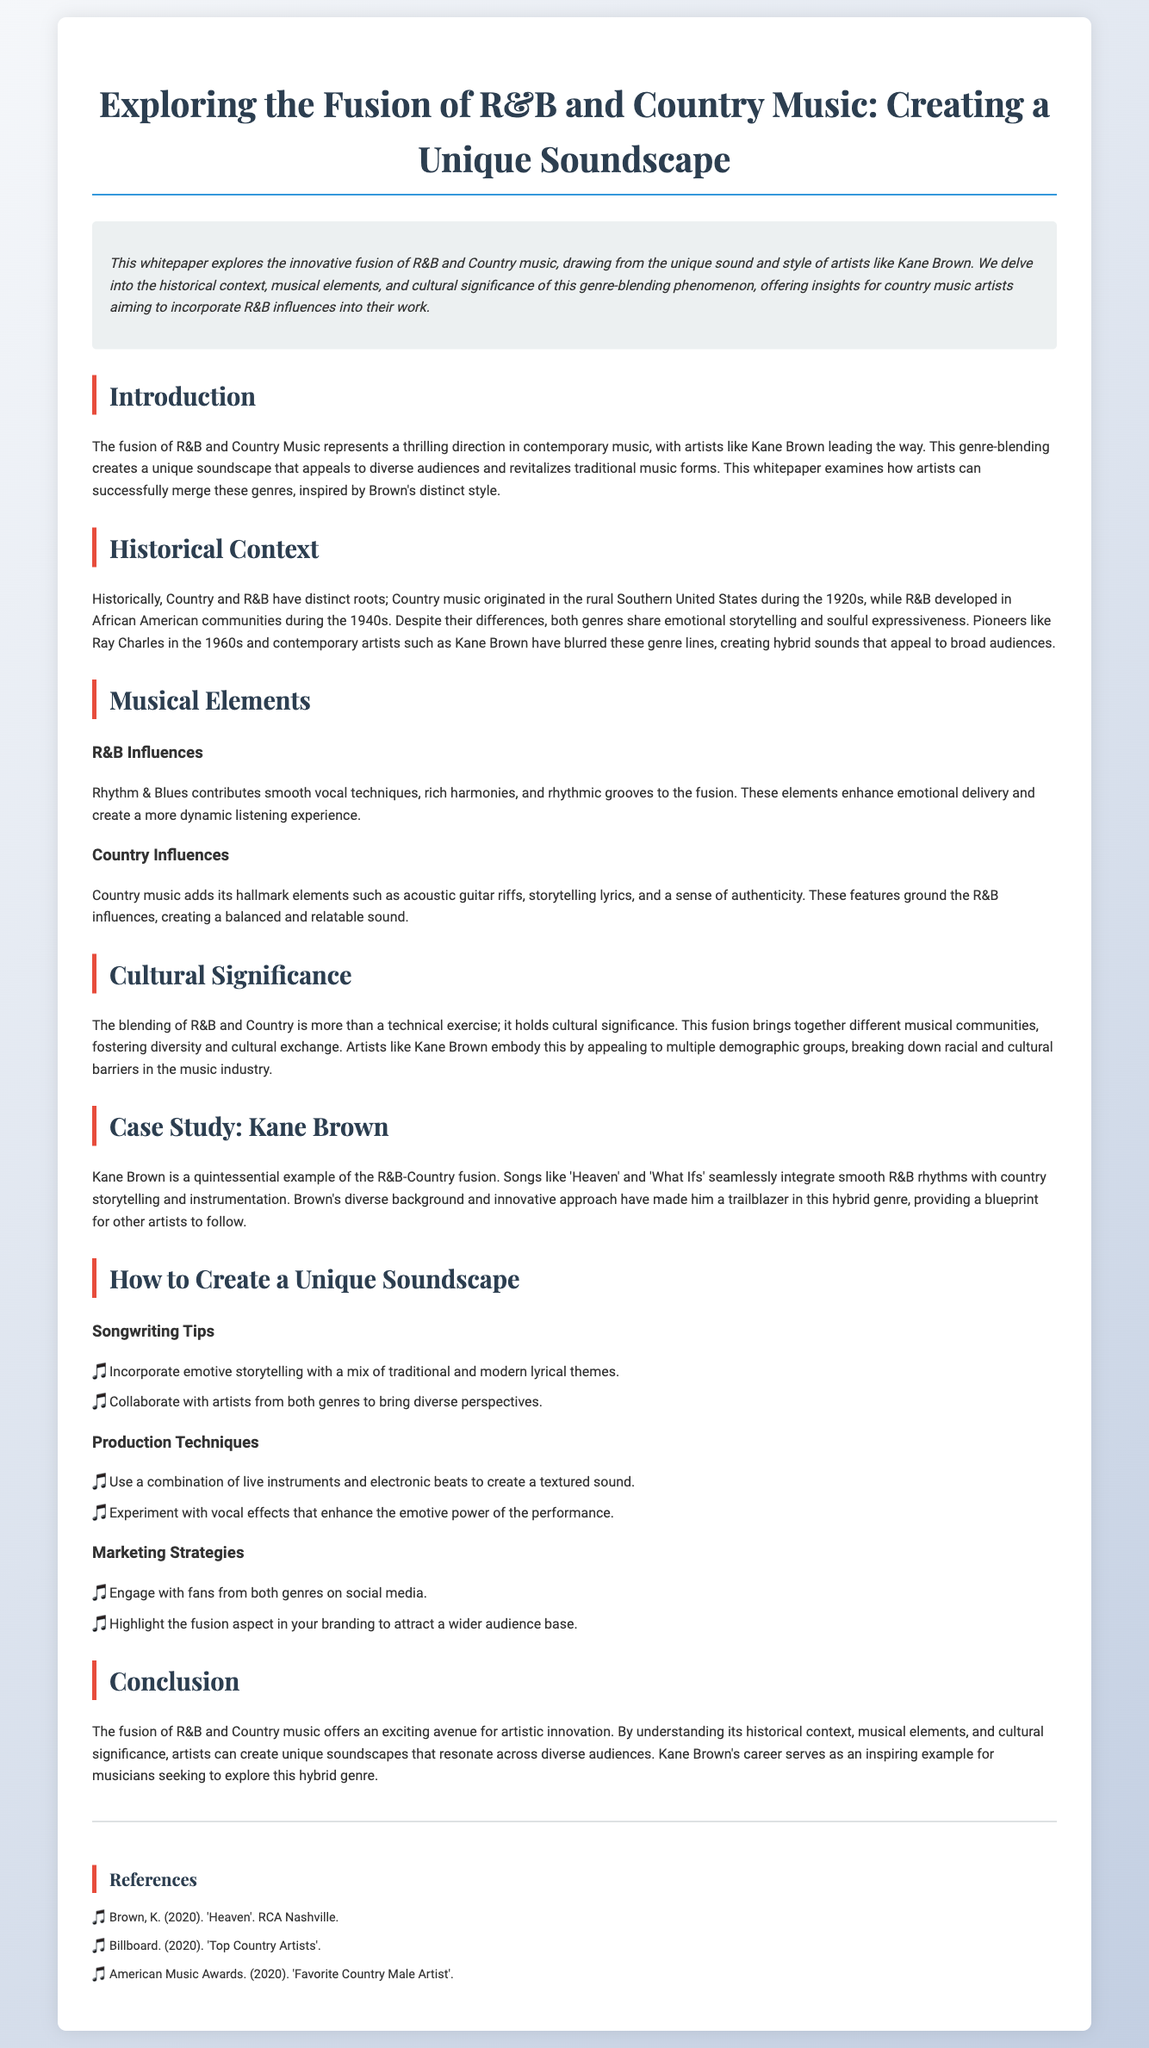What is the title of the whitepaper? The title is prominently displayed at the beginning of the document, which describes the fusion of two music genres.
Answer: Exploring the Fusion of R&B and Country Music: Creating a Unique Soundscape Who is a key artist mentioned in the document? The document highlights the work of a specific artist known for blending R&B and Country music styles.
Answer: Kane Brown What decade did Country music originate? The historical context section of the document discusses the origins of Country music, specifying the time period.
Answer: 1920s Which song by Kane Brown is mentioned as an example of the fusion? A specific song is cited as an exemplar of the unique sound created by blending R&B and Country elements.
Answer: Heaven What are two songwriting tips provided in the document? The whitepaper lists practical advice for artists looking to merge these genres, particularly in songwriting.
Answer: Emotive storytelling, collaborate with artists from both genres What is the cultural significance of the R&B-Country fusion? The document elaborates on the broader impact of blending these genres on community and cultural exchange.
Answer: Fostering diversity and cultural exchange What production technique is suggested for creating a unique sound? The whitepaper discusses various techniques that artists can employ in their production processes.
Answer: Combination of live instruments and electronic beats Which genre developed in African American communities? The document provides historical context that differentiates the roots of the two music genres.
Answer: R&B What aspect should artists highlight in their branding? The marketing strategies section outlines how artists can attract a diverse audience.
Answer: The fusion aspect 